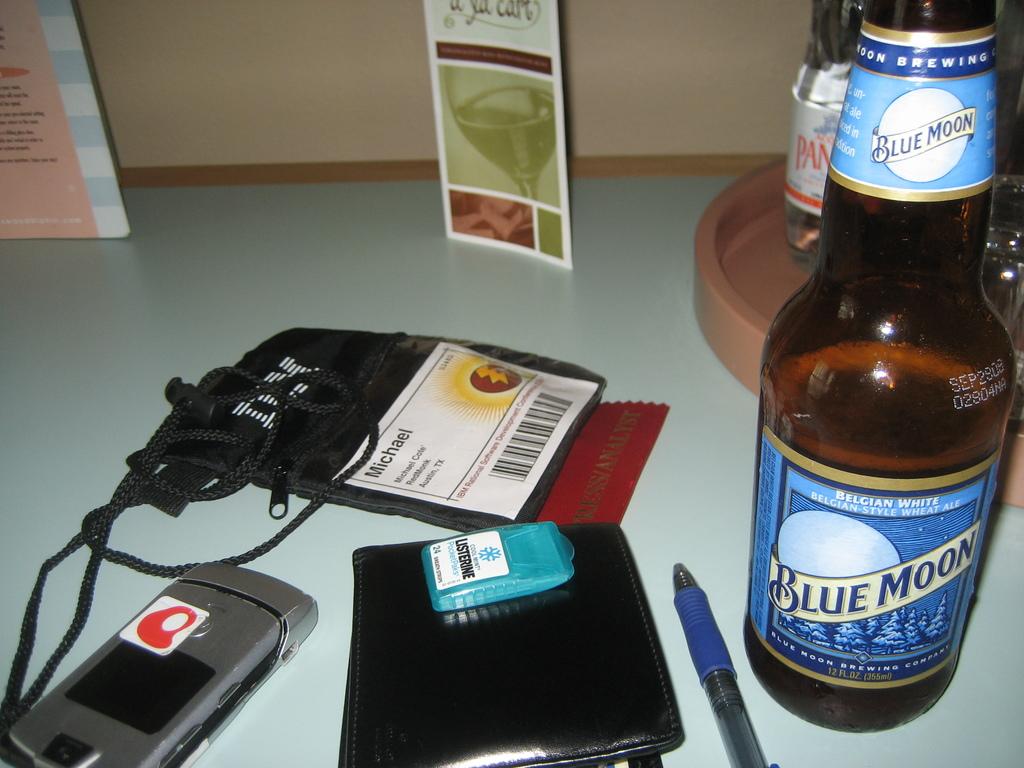What is the brand of the ale?
Provide a succinct answer. Blue moon. What is the first name on the id badge in the middle of the table?
Your response must be concise. Michael. 